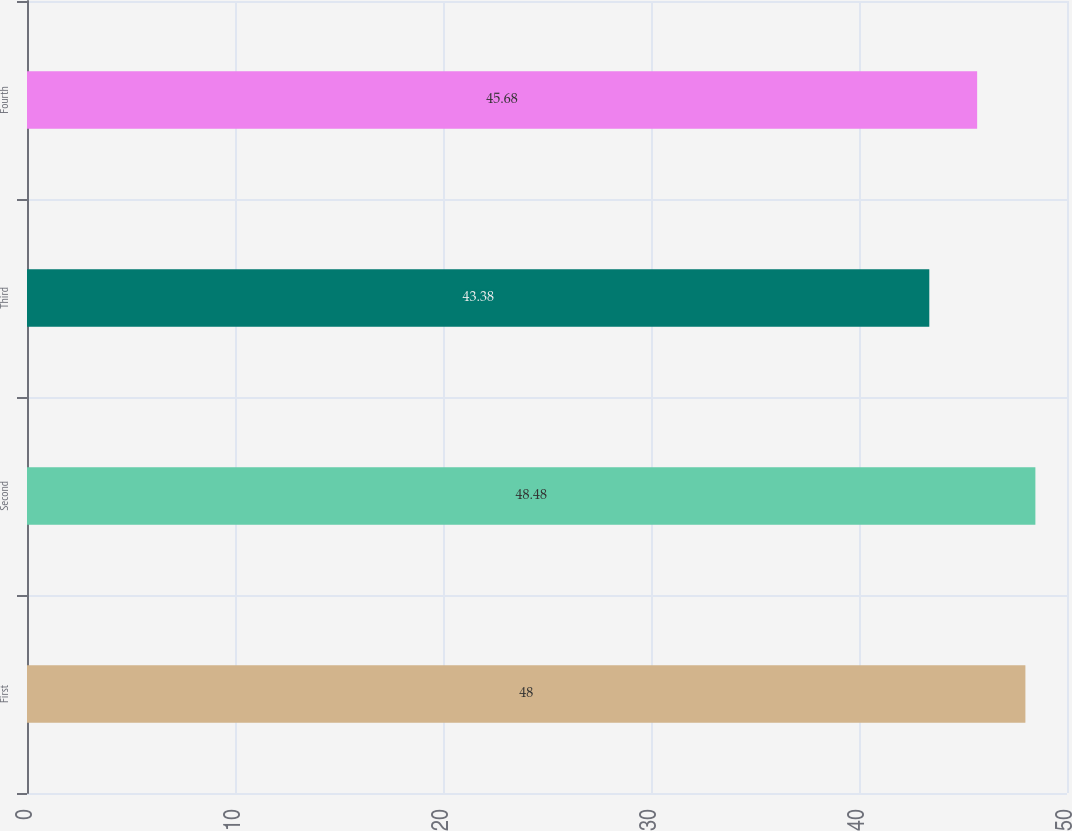Convert chart. <chart><loc_0><loc_0><loc_500><loc_500><bar_chart><fcel>First<fcel>Second<fcel>Third<fcel>Fourth<nl><fcel>48<fcel>48.48<fcel>43.38<fcel>45.68<nl></chart> 